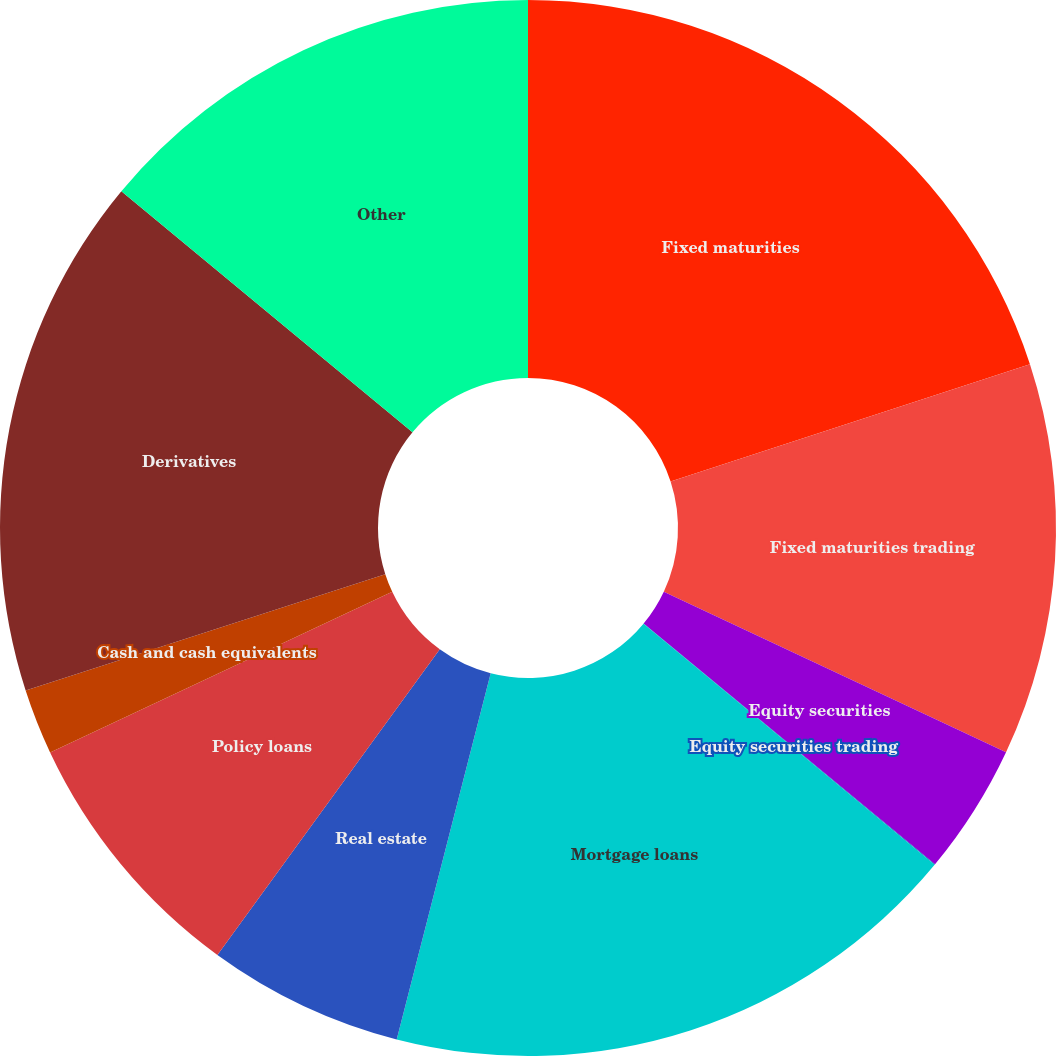Convert chart. <chart><loc_0><loc_0><loc_500><loc_500><pie_chart><fcel>Fixed maturities<fcel>Fixed maturities trading<fcel>Equity securities<fcel>Equity securities trading<fcel>Mortgage loans<fcel>Real estate<fcel>Policy loans<fcel>Cash and cash equivalents<fcel>Derivatives<fcel>Other<nl><fcel>19.98%<fcel>12.0%<fcel>4.01%<fcel>0.02%<fcel>17.99%<fcel>6.01%<fcel>8.0%<fcel>2.01%<fcel>15.99%<fcel>13.99%<nl></chart> 